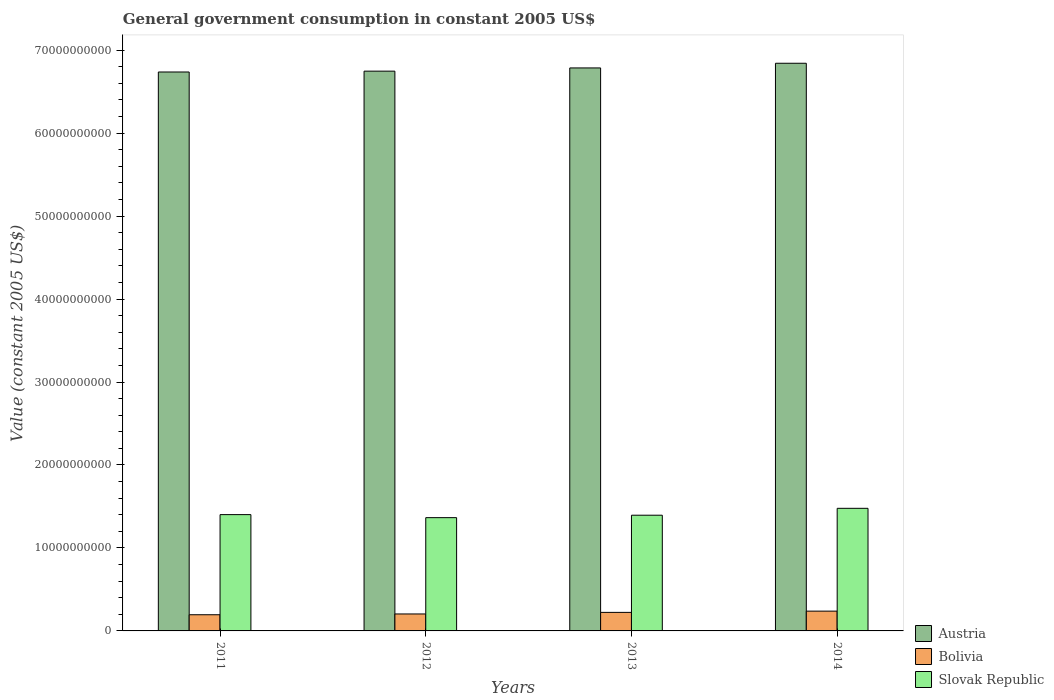How many different coloured bars are there?
Your response must be concise. 3. How many groups of bars are there?
Keep it short and to the point. 4. Are the number of bars per tick equal to the number of legend labels?
Keep it short and to the point. Yes. How many bars are there on the 4th tick from the right?
Offer a terse response. 3. In how many cases, is the number of bars for a given year not equal to the number of legend labels?
Keep it short and to the point. 0. What is the government conusmption in Slovak Republic in 2012?
Provide a short and direct response. 1.37e+1. Across all years, what is the maximum government conusmption in Austria?
Your response must be concise. 6.84e+1. Across all years, what is the minimum government conusmption in Slovak Republic?
Give a very brief answer. 1.37e+1. What is the total government conusmption in Austria in the graph?
Your response must be concise. 2.71e+11. What is the difference between the government conusmption in Slovak Republic in 2012 and that in 2014?
Your answer should be very brief. -1.12e+09. What is the difference between the government conusmption in Slovak Republic in 2014 and the government conusmption in Bolivia in 2012?
Your response must be concise. 1.27e+1. What is the average government conusmption in Austria per year?
Your answer should be very brief. 6.78e+1. In the year 2013, what is the difference between the government conusmption in Slovak Republic and government conusmption in Austria?
Keep it short and to the point. -5.39e+1. In how many years, is the government conusmption in Bolivia greater than 60000000000 US$?
Make the answer very short. 0. What is the ratio of the government conusmption in Slovak Republic in 2012 to that in 2013?
Offer a terse response. 0.98. What is the difference between the highest and the second highest government conusmption in Bolivia?
Provide a short and direct response. 1.50e+08. What is the difference between the highest and the lowest government conusmption in Bolivia?
Provide a short and direct response. 4.35e+08. In how many years, is the government conusmption in Austria greater than the average government conusmption in Austria taken over all years?
Offer a terse response. 2. What does the 3rd bar from the left in 2012 represents?
Provide a short and direct response. Slovak Republic. What does the 2nd bar from the right in 2013 represents?
Ensure brevity in your answer.  Bolivia. Is it the case that in every year, the sum of the government conusmption in Slovak Republic and government conusmption in Bolivia is greater than the government conusmption in Austria?
Provide a succinct answer. No. Are all the bars in the graph horizontal?
Ensure brevity in your answer.  No. Are the values on the major ticks of Y-axis written in scientific E-notation?
Give a very brief answer. No. Does the graph contain any zero values?
Ensure brevity in your answer.  No. Does the graph contain grids?
Give a very brief answer. No. Where does the legend appear in the graph?
Your response must be concise. Bottom right. What is the title of the graph?
Provide a short and direct response. General government consumption in constant 2005 US$. What is the label or title of the Y-axis?
Your response must be concise. Value (constant 2005 US$). What is the Value (constant 2005 US$) of Austria in 2011?
Make the answer very short. 6.74e+1. What is the Value (constant 2005 US$) of Bolivia in 2011?
Your response must be concise. 1.95e+09. What is the Value (constant 2005 US$) in Slovak Republic in 2011?
Provide a succinct answer. 1.40e+1. What is the Value (constant 2005 US$) of Austria in 2012?
Provide a short and direct response. 6.75e+1. What is the Value (constant 2005 US$) in Bolivia in 2012?
Make the answer very short. 2.04e+09. What is the Value (constant 2005 US$) of Slovak Republic in 2012?
Make the answer very short. 1.37e+1. What is the Value (constant 2005 US$) of Austria in 2013?
Offer a terse response. 6.79e+1. What is the Value (constant 2005 US$) of Bolivia in 2013?
Your response must be concise. 2.23e+09. What is the Value (constant 2005 US$) in Slovak Republic in 2013?
Ensure brevity in your answer.  1.39e+1. What is the Value (constant 2005 US$) of Austria in 2014?
Make the answer very short. 6.84e+1. What is the Value (constant 2005 US$) of Bolivia in 2014?
Give a very brief answer. 2.38e+09. What is the Value (constant 2005 US$) of Slovak Republic in 2014?
Offer a terse response. 1.48e+1. Across all years, what is the maximum Value (constant 2005 US$) of Austria?
Keep it short and to the point. 6.84e+1. Across all years, what is the maximum Value (constant 2005 US$) in Bolivia?
Keep it short and to the point. 2.38e+09. Across all years, what is the maximum Value (constant 2005 US$) in Slovak Republic?
Your response must be concise. 1.48e+1. Across all years, what is the minimum Value (constant 2005 US$) of Austria?
Keep it short and to the point. 6.74e+1. Across all years, what is the minimum Value (constant 2005 US$) in Bolivia?
Provide a succinct answer. 1.95e+09. Across all years, what is the minimum Value (constant 2005 US$) of Slovak Republic?
Offer a terse response. 1.37e+1. What is the total Value (constant 2005 US$) in Austria in the graph?
Make the answer very short. 2.71e+11. What is the total Value (constant 2005 US$) in Bolivia in the graph?
Your response must be concise. 8.61e+09. What is the total Value (constant 2005 US$) in Slovak Republic in the graph?
Provide a short and direct response. 5.64e+1. What is the difference between the Value (constant 2005 US$) of Austria in 2011 and that in 2012?
Your response must be concise. -1.02e+08. What is the difference between the Value (constant 2005 US$) in Bolivia in 2011 and that in 2012?
Provide a short and direct response. -9.52e+07. What is the difference between the Value (constant 2005 US$) of Slovak Republic in 2011 and that in 2012?
Provide a succinct answer. 3.65e+08. What is the difference between the Value (constant 2005 US$) of Austria in 2011 and that in 2013?
Offer a very short reply. -4.90e+08. What is the difference between the Value (constant 2005 US$) in Bolivia in 2011 and that in 2013?
Provide a succinct answer. -2.85e+08. What is the difference between the Value (constant 2005 US$) of Slovak Republic in 2011 and that in 2013?
Provide a succinct answer. 7.08e+07. What is the difference between the Value (constant 2005 US$) in Austria in 2011 and that in 2014?
Your answer should be compact. -1.05e+09. What is the difference between the Value (constant 2005 US$) in Bolivia in 2011 and that in 2014?
Ensure brevity in your answer.  -4.35e+08. What is the difference between the Value (constant 2005 US$) of Slovak Republic in 2011 and that in 2014?
Keep it short and to the point. -7.59e+08. What is the difference between the Value (constant 2005 US$) in Austria in 2012 and that in 2013?
Provide a succinct answer. -3.88e+08. What is the difference between the Value (constant 2005 US$) of Bolivia in 2012 and that in 2013?
Make the answer very short. -1.90e+08. What is the difference between the Value (constant 2005 US$) in Slovak Republic in 2012 and that in 2013?
Provide a succinct answer. -2.94e+08. What is the difference between the Value (constant 2005 US$) in Austria in 2012 and that in 2014?
Offer a very short reply. -9.51e+08. What is the difference between the Value (constant 2005 US$) in Bolivia in 2012 and that in 2014?
Keep it short and to the point. -3.40e+08. What is the difference between the Value (constant 2005 US$) in Slovak Republic in 2012 and that in 2014?
Your answer should be compact. -1.12e+09. What is the difference between the Value (constant 2005 US$) of Austria in 2013 and that in 2014?
Offer a terse response. -5.62e+08. What is the difference between the Value (constant 2005 US$) of Bolivia in 2013 and that in 2014?
Give a very brief answer. -1.50e+08. What is the difference between the Value (constant 2005 US$) of Slovak Republic in 2013 and that in 2014?
Keep it short and to the point. -8.30e+08. What is the difference between the Value (constant 2005 US$) of Austria in 2011 and the Value (constant 2005 US$) of Bolivia in 2012?
Your response must be concise. 6.53e+1. What is the difference between the Value (constant 2005 US$) of Austria in 2011 and the Value (constant 2005 US$) of Slovak Republic in 2012?
Make the answer very short. 5.37e+1. What is the difference between the Value (constant 2005 US$) in Bolivia in 2011 and the Value (constant 2005 US$) in Slovak Republic in 2012?
Provide a short and direct response. -1.17e+1. What is the difference between the Value (constant 2005 US$) in Austria in 2011 and the Value (constant 2005 US$) in Bolivia in 2013?
Make the answer very short. 6.51e+1. What is the difference between the Value (constant 2005 US$) in Austria in 2011 and the Value (constant 2005 US$) in Slovak Republic in 2013?
Ensure brevity in your answer.  5.34e+1. What is the difference between the Value (constant 2005 US$) in Bolivia in 2011 and the Value (constant 2005 US$) in Slovak Republic in 2013?
Ensure brevity in your answer.  -1.20e+1. What is the difference between the Value (constant 2005 US$) of Austria in 2011 and the Value (constant 2005 US$) of Bolivia in 2014?
Keep it short and to the point. 6.50e+1. What is the difference between the Value (constant 2005 US$) of Austria in 2011 and the Value (constant 2005 US$) of Slovak Republic in 2014?
Offer a very short reply. 5.26e+1. What is the difference between the Value (constant 2005 US$) of Bolivia in 2011 and the Value (constant 2005 US$) of Slovak Republic in 2014?
Offer a very short reply. -1.28e+1. What is the difference between the Value (constant 2005 US$) of Austria in 2012 and the Value (constant 2005 US$) of Bolivia in 2013?
Keep it short and to the point. 6.52e+1. What is the difference between the Value (constant 2005 US$) in Austria in 2012 and the Value (constant 2005 US$) in Slovak Republic in 2013?
Keep it short and to the point. 5.35e+1. What is the difference between the Value (constant 2005 US$) in Bolivia in 2012 and the Value (constant 2005 US$) in Slovak Republic in 2013?
Provide a succinct answer. -1.19e+1. What is the difference between the Value (constant 2005 US$) in Austria in 2012 and the Value (constant 2005 US$) in Bolivia in 2014?
Keep it short and to the point. 6.51e+1. What is the difference between the Value (constant 2005 US$) in Austria in 2012 and the Value (constant 2005 US$) in Slovak Republic in 2014?
Your answer should be compact. 5.27e+1. What is the difference between the Value (constant 2005 US$) in Bolivia in 2012 and the Value (constant 2005 US$) in Slovak Republic in 2014?
Offer a very short reply. -1.27e+1. What is the difference between the Value (constant 2005 US$) in Austria in 2013 and the Value (constant 2005 US$) in Bolivia in 2014?
Offer a very short reply. 6.55e+1. What is the difference between the Value (constant 2005 US$) of Austria in 2013 and the Value (constant 2005 US$) of Slovak Republic in 2014?
Make the answer very short. 5.31e+1. What is the difference between the Value (constant 2005 US$) of Bolivia in 2013 and the Value (constant 2005 US$) of Slovak Republic in 2014?
Offer a terse response. -1.25e+1. What is the average Value (constant 2005 US$) in Austria per year?
Your answer should be compact. 6.78e+1. What is the average Value (constant 2005 US$) of Bolivia per year?
Your answer should be very brief. 2.15e+09. What is the average Value (constant 2005 US$) of Slovak Republic per year?
Make the answer very short. 1.41e+1. In the year 2011, what is the difference between the Value (constant 2005 US$) in Austria and Value (constant 2005 US$) in Bolivia?
Offer a very short reply. 6.54e+1. In the year 2011, what is the difference between the Value (constant 2005 US$) of Austria and Value (constant 2005 US$) of Slovak Republic?
Ensure brevity in your answer.  5.33e+1. In the year 2011, what is the difference between the Value (constant 2005 US$) of Bolivia and Value (constant 2005 US$) of Slovak Republic?
Give a very brief answer. -1.21e+1. In the year 2012, what is the difference between the Value (constant 2005 US$) of Austria and Value (constant 2005 US$) of Bolivia?
Offer a terse response. 6.54e+1. In the year 2012, what is the difference between the Value (constant 2005 US$) of Austria and Value (constant 2005 US$) of Slovak Republic?
Provide a succinct answer. 5.38e+1. In the year 2012, what is the difference between the Value (constant 2005 US$) in Bolivia and Value (constant 2005 US$) in Slovak Republic?
Your answer should be compact. -1.16e+1. In the year 2013, what is the difference between the Value (constant 2005 US$) in Austria and Value (constant 2005 US$) in Bolivia?
Your answer should be compact. 6.56e+1. In the year 2013, what is the difference between the Value (constant 2005 US$) of Austria and Value (constant 2005 US$) of Slovak Republic?
Your answer should be compact. 5.39e+1. In the year 2013, what is the difference between the Value (constant 2005 US$) of Bolivia and Value (constant 2005 US$) of Slovak Republic?
Provide a succinct answer. -1.17e+1. In the year 2014, what is the difference between the Value (constant 2005 US$) of Austria and Value (constant 2005 US$) of Bolivia?
Ensure brevity in your answer.  6.60e+1. In the year 2014, what is the difference between the Value (constant 2005 US$) in Austria and Value (constant 2005 US$) in Slovak Republic?
Your answer should be very brief. 5.36e+1. In the year 2014, what is the difference between the Value (constant 2005 US$) in Bolivia and Value (constant 2005 US$) in Slovak Republic?
Your answer should be compact. -1.24e+1. What is the ratio of the Value (constant 2005 US$) of Bolivia in 2011 to that in 2012?
Ensure brevity in your answer.  0.95. What is the ratio of the Value (constant 2005 US$) of Slovak Republic in 2011 to that in 2012?
Your answer should be compact. 1.03. What is the ratio of the Value (constant 2005 US$) of Austria in 2011 to that in 2013?
Provide a short and direct response. 0.99. What is the ratio of the Value (constant 2005 US$) of Bolivia in 2011 to that in 2013?
Your answer should be very brief. 0.87. What is the ratio of the Value (constant 2005 US$) in Austria in 2011 to that in 2014?
Give a very brief answer. 0.98. What is the ratio of the Value (constant 2005 US$) of Bolivia in 2011 to that in 2014?
Make the answer very short. 0.82. What is the ratio of the Value (constant 2005 US$) of Slovak Republic in 2011 to that in 2014?
Give a very brief answer. 0.95. What is the ratio of the Value (constant 2005 US$) of Austria in 2012 to that in 2013?
Make the answer very short. 0.99. What is the ratio of the Value (constant 2005 US$) in Bolivia in 2012 to that in 2013?
Your response must be concise. 0.92. What is the ratio of the Value (constant 2005 US$) of Slovak Republic in 2012 to that in 2013?
Your response must be concise. 0.98. What is the ratio of the Value (constant 2005 US$) of Austria in 2012 to that in 2014?
Make the answer very short. 0.99. What is the ratio of the Value (constant 2005 US$) in Bolivia in 2012 to that in 2014?
Provide a short and direct response. 0.86. What is the ratio of the Value (constant 2005 US$) of Slovak Republic in 2012 to that in 2014?
Make the answer very short. 0.92. What is the ratio of the Value (constant 2005 US$) of Bolivia in 2013 to that in 2014?
Provide a short and direct response. 0.94. What is the ratio of the Value (constant 2005 US$) of Slovak Republic in 2013 to that in 2014?
Your answer should be compact. 0.94. What is the difference between the highest and the second highest Value (constant 2005 US$) in Austria?
Provide a succinct answer. 5.62e+08. What is the difference between the highest and the second highest Value (constant 2005 US$) in Bolivia?
Offer a very short reply. 1.50e+08. What is the difference between the highest and the second highest Value (constant 2005 US$) of Slovak Republic?
Your response must be concise. 7.59e+08. What is the difference between the highest and the lowest Value (constant 2005 US$) in Austria?
Give a very brief answer. 1.05e+09. What is the difference between the highest and the lowest Value (constant 2005 US$) in Bolivia?
Offer a very short reply. 4.35e+08. What is the difference between the highest and the lowest Value (constant 2005 US$) in Slovak Republic?
Your answer should be very brief. 1.12e+09. 